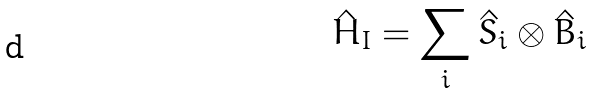Convert formula to latex. <formula><loc_0><loc_0><loc_500><loc_500>\hat { H } _ { I } = \sum _ { i } \hat { S } _ { i } \otimes \hat { B } _ { i }</formula> 